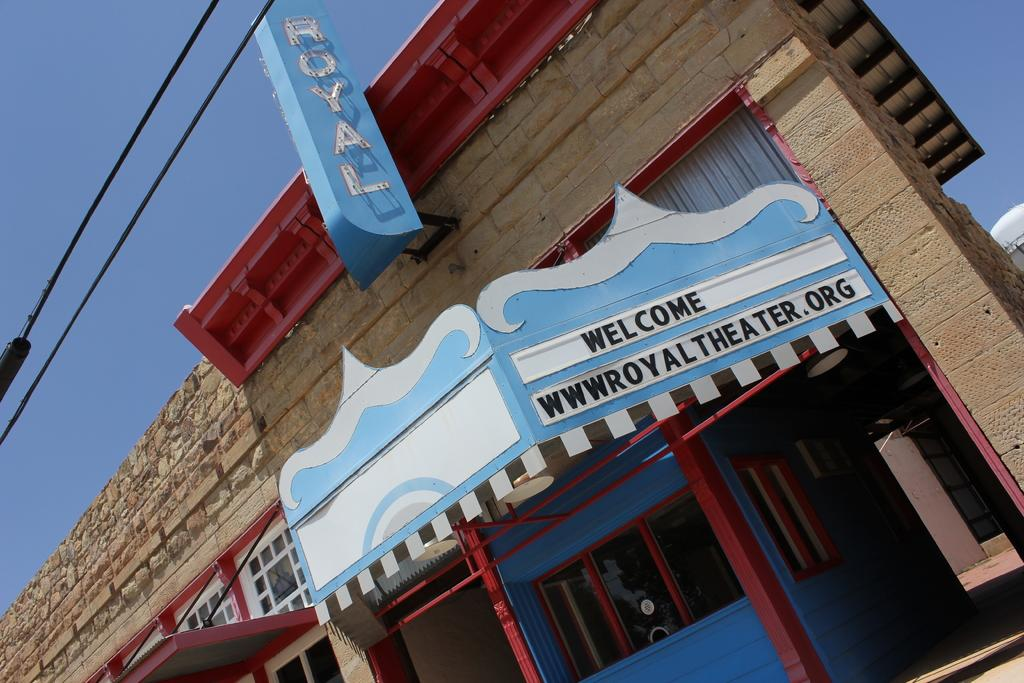<image>
Offer a succinct explanation of the picture presented. A building with a blue sign that says Welcome to Royal Theater. 